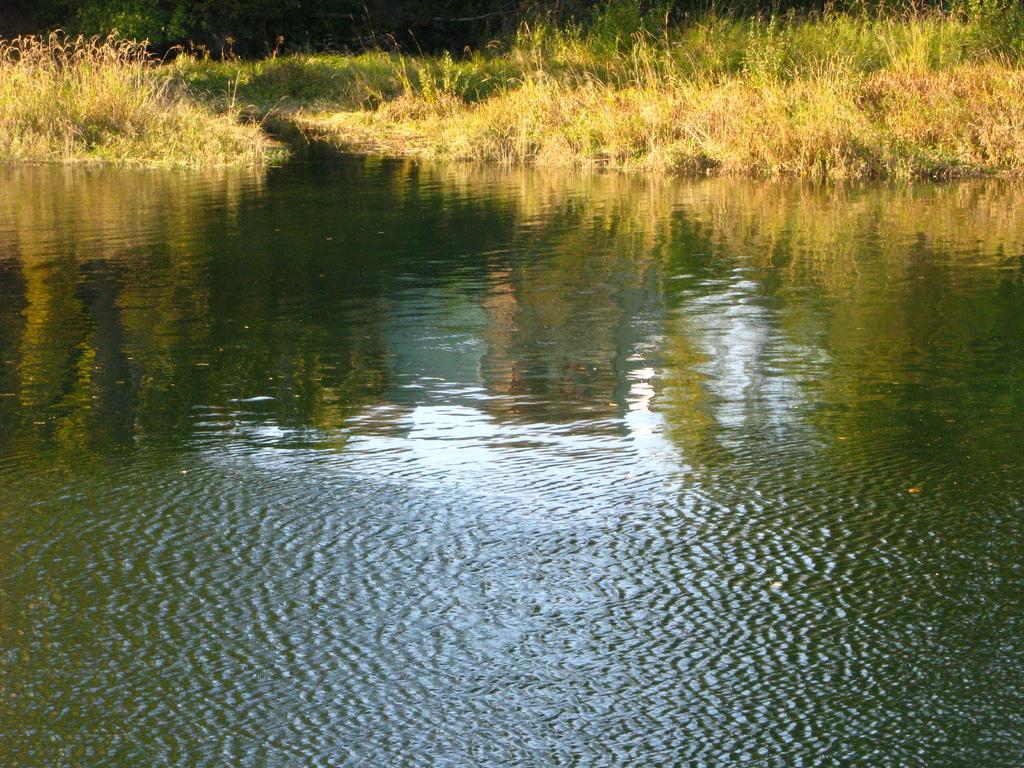Could you give a brief overview of what you see in this image? In this image, I can see water, grass and plants. 